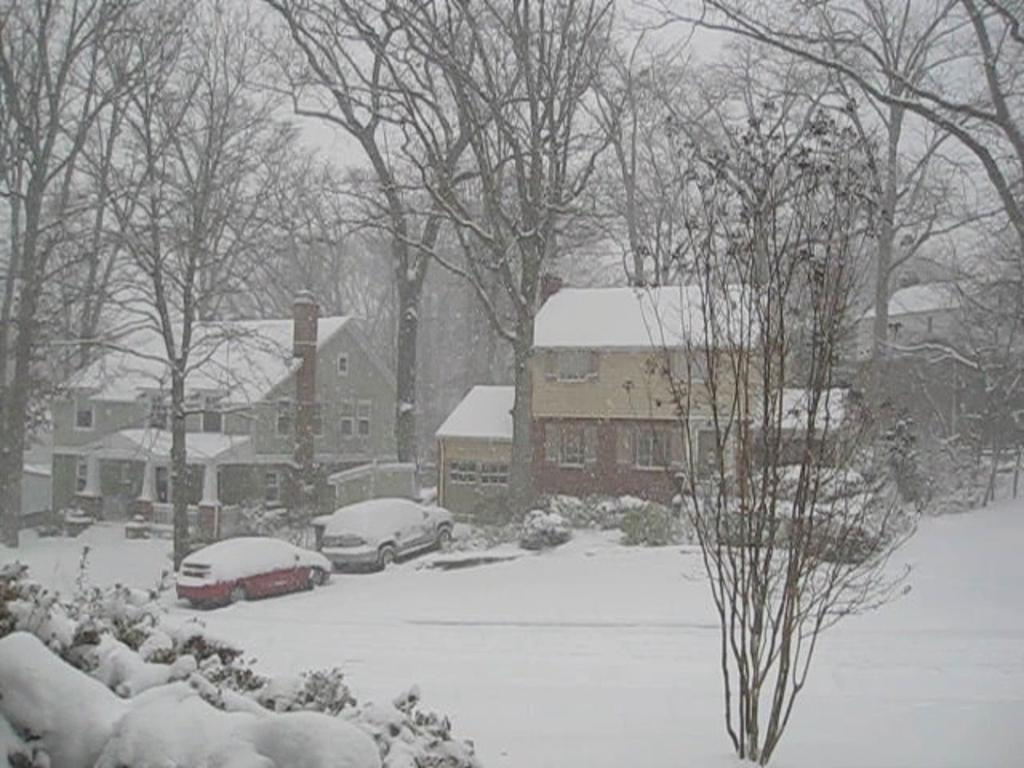What type of natural elements can be seen in the image? There are trees, bushes, and plants in the image. What type of man-made structures are present in the image? There are buildings in the image. What mode of transportation can be seen in the image? Motor vehicles are present in the image. How is the weather depicted in the image? The motor vehicles are covered with snow, suggesting a snowy environment. What is visible in the background of the image? The sky is visible in the background of the image. What type of dress is being worn by the tree in the image? There is no dress present in the image, as trees are not capable of wearing clothing. What type of polish is being applied to the bushes in the image? There is no polish being applied to the bushes in the image; they are natural elements and do not require polishing. 